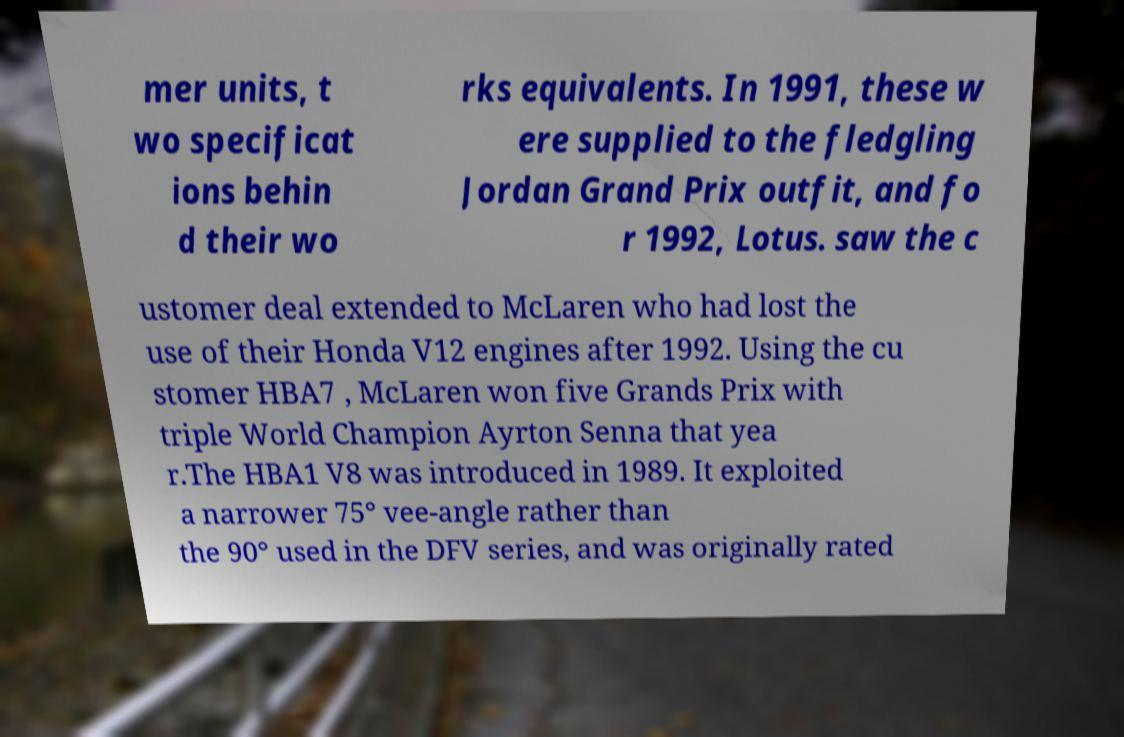Please identify and transcribe the text found in this image. mer units, t wo specificat ions behin d their wo rks equivalents. In 1991, these w ere supplied to the fledgling Jordan Grand Prix outfit, and fo r 1992, Lotus. saw the c ustomer deal extended to McLaren who had lost the use of their Honda V12 engines after 1992. Using the cu stomer HBA7 , McLaren won five Grands Prix with triple World Champion Ayrton Senna that yea r.The HBA1 V8 was introduced in 1989. It exploited a narrower 75° vee-angle rather than the 90° used in the DFV series, and was originally rated 